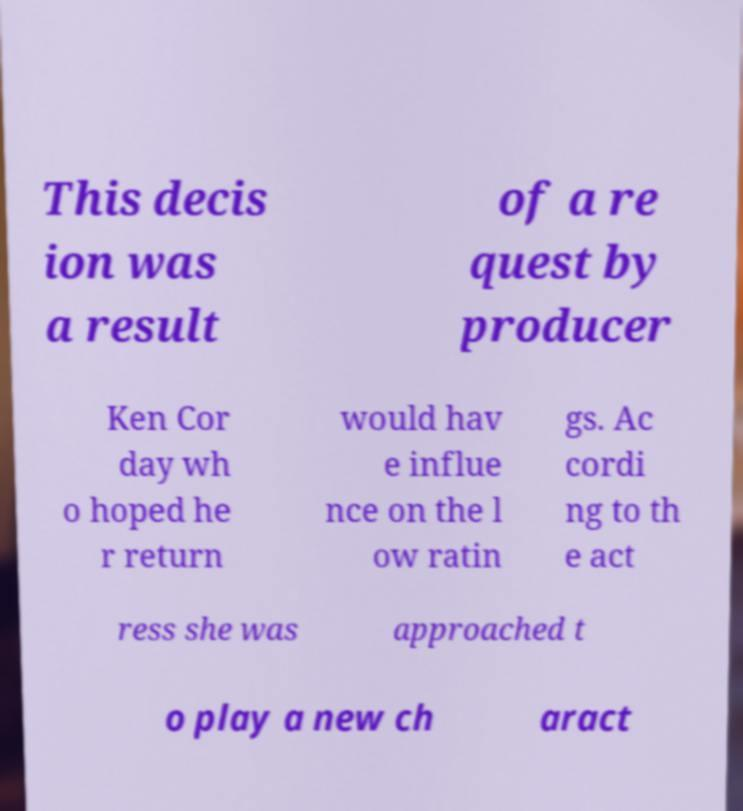Can you accurately transcribe the text from the provided image for me? This decis ion was a result of a re quest by producer Ken Cor day wh o hoped he r return would hav e influe nce on the l ow ratin gs. Ac cordi ng to th e act ress she was approached t o play a new ch aract 